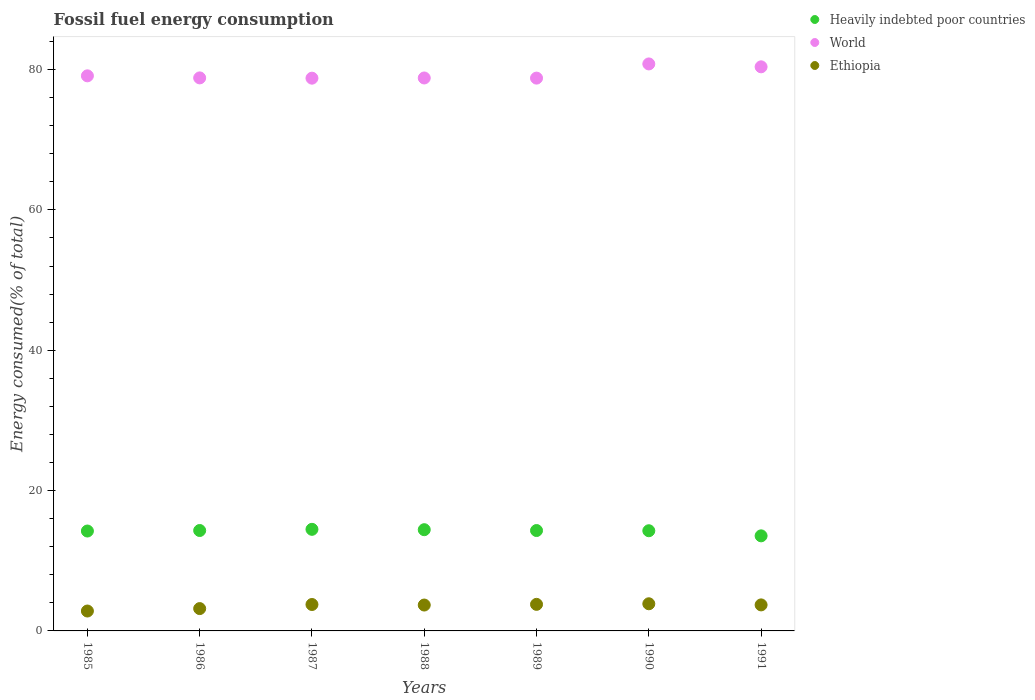How many different coloured dotlines are there?
Make the answer very short. 3. Is the number of dotlines equal to the number of legend labels?
Your answer should be very brief. Yes. What is the percentage of energy consumed in Ethiopia in 1985?
Make the answer very short. 2.84. Across all years, what is the maximum percentage of energy consumed in Heavily indebted poor countries?
Make the answer very short. 14.48. Across all years, what is the minimum percentage of energy consumed in World?
Your answer should be very brief. 78.77. In which year was the percentage of energy consumed in Ethiopia maximum?
Your response must be concise. 1990. What is the total percentage of energy consumed in Ethiopia in the graph?
Offer a very short reply. 24.83. What is the difference between the percentage of energy consumed in Ethiopia in 1987 and that in 1990?
Keep it short and to the point. -0.1. What is the difference between the percentage of energy consumed in World in 1989 and the percentage of energy consumed in Heavily indebted poor countries in 1986?
Provide a short and direct response. 64.47. What is the average percentage of energy consumed in Heavily indebted poor countries per year?
Your answer should be compact. 14.23. In the year 1988, what is the difference between the percentage of energy consumed in Ethiopia and percentage of energy consumed in World?
Provide a short and direct response. -75.11. What is the ratio of the percentage of energy consumed in World in 1985 to that in 1988?
Provide a short and direct response. 1. Is the difference between the percentage of energy consumed in Ethiopia in 1987 and 1990 greater than the difference between the percentage of energy consumed in World in 1987 and 1990?
Your answer should be compact. Yes. What is the difference between the highest and the second highest percentage of energy consumed in World?
Provide a short and direct response. 0.41. What is the difference between the highest and the lowest percentage of energy consumed in Heavily indebted poor countries?
Provide a succinct answer. 0.93. Is it the case that in every year, the sum of the percentage of energy consumed in World and percentage of energy consumed in Ethiopia  is greater than the percentage of energy consumed in Heavily indebted poor countries?
Offer a very short reply. Yes. Is the percentage of energy consumed in Ethiopia strictly greater than the percentage of energy consumed in Heavily indebted poor countries over the years?
Provide a succinct answer. No. Is the percentage of energy consumed in World strictly less than the percentage of energy consumed in Ethiopia over the years?
Your answer should be very brief. No. How many years are there in the graph?
Keep it short and to the point. 7. What is the difference between two consecutive major ticks on the Y-axis?
Offer a terse response. 20. Are the values on the major ticks of Y-axis written in scientific E-notation?
Your answer should be compact. No. Does the graph contain any zero values?
Give a very brief answer. No. What is the title of the graph?
Make the answer very short. Fossil fuel energy consumption. What is the label or title of the Y-axis?
Your answer should be very brief. Energy consumed(% of total). What is the Energy consumed(% of total) in Heavily indebted poor countries in 1985?
Your response must be concise. 14.24. What is the Energy consumed(% of total) in World in 1985?
Offer a terse response. 79.1. What is the Energy consumed(% of total) of Ethiopia in 1985?
Ensure brevity in your answer.  2.84. What is the Energy consumed(% of total) of Heavily indebted poor countries in 1986?
Offer a very short reply. 14.31. What is the Energy consumed(% of total) in World in 1986?
Ensure brevity in your answer.  78.81. What is the Energy consumed(% of total) in Ethiopia in 1986?
Make the answer very short. 3.18. What is the Energy consumed(% of total) in Heavily indebted poor countries in 1987?
Ensure brevity in your answer.  14.48. What is the Energy consumed(% of total) of World in 1987?
Your answer should be very brief. 78.77. What is the Energy consumed(% of total) of Ethiopia in 1987?
Offer a terse response. 3.76. What is the Energy consumed(% of total) in Heavily indebted poor countries in 1988?
Offer a very short reply. 14.43. What is the Energy consumed(% of total) in World in 1988?
Provide a short and direct response. 78.8. What is the Energy consumed(% of total) in Ethiopia in 1988?
Provide a succinct answer. 3.69. What is the Energy consumed(% of total) of Heavily indebted poor countries in 1989?
Keep it short and to the point. 14.31. What is the Energy consumed(% of total) of World in 1989?
Give a very brief answer. 78.78. What is the Energy consumed(% of total) in Ethiopia in 1989?
Your answer should be compact. 3.79. What is the Energy consumed(% of total) in Heavily indebted poor countries in 1990?
Keep it short and to the point. 14.28. What is the Energy consumed(% of total) of World in 1990?
Your response must be concise. 80.8. What is the Energy consumed(% of total) of Ethiopia in 1990?
Offer a terse response. 3.87. What is the Energy consumed(% of total) of Heavily indebted poor countries in 1991?
Make the answer very short. 13.55. What is the Energy consumed(% of total) of World in 1991?
Make the answer very short. 80.39. What is the Energy consumed(% of total) in Ethiopia in 1991?
Your answer should be compact. 3.71. Across all years, what is the maximum Energy consumed(% of total) in Heavily indebted poor countries?
Your answer should be very brief. 14.48. Across all years, what is the maximum Energy consumed(% of total) of World?
Offer a terse response. 80.8. Across all years, what is the maximum Energy consumed(% of total) of Ethiopia?
Give a very brief answer. 3.87. Across all years, what is the minimum Energy consumed(% of total) in Heavily indebted poor countries?
Offer a very short reply. 13.55. Across all years, what is the minimum Energy consumed(% of total) in World?
Your answer should be compact. 78.77. Across all years, what is the minimum Energy consumed(% of total) of Ethiopia?
Make the answer very short. 2.84. What is the total Energy consumed(% of total) in Heavily indebted poor countries in the graph?
Your response must be concise. 99.58. What is the total Energy consumed(% of total) of World in the graph?
Your answer should be compact. 555.46. What is the total Energy consumed(% of total) of Ethiopia in the graph?
Keep it short and to the point. 24.83. What is the difference between the Energy consumed(% of total) of Heavily indebted poor countries in 1985 and that in 1986?
Offer a terse response. -0.07. What is the difference between the Energy consumed(% of total) of World in 1985 and that in 1986?
Ensure brevity in your answer.  0.29. What is the difference between the Energy consumed(% of total) of Ethiopia in 1985 and that in 1986?
Your answer should be compact. -0.35. What is the difference between the Energy consumed(% of total) of Heavily indebted poor countries in 1985 and that in 1987?
Offer a terse response. -0.24. What is the difference between the Energy consumed(% of total) of World in 1985 and that in 1987?
Provide a short and direct response. 0.33. What is the difference between the Energy consumed(% of total) of Ethiopia in 1985 and that in 1987?
Provide a succinct answer. -0.93. What is the difference between the Energy consumed(% of total) of Heavily indebted poor countries in 1985 and that in 1988?
Your answer should be compact. -0.19. What is the difference between the Energy consumed(% of total) of World in 1985 and that in 1988?
Ensure brevity in your answer.  0.3. What is the difference between the Energy consumed(% of total) of Ethiopia in 1985 and that in 1988?
Ensure brevity in your answer.  -0.85. What is the difference between the Energy consumed(% of total) in Heavily indebted poor countries in 1985 and that in 1989?
Provide a short and direct response. -0.07. What is the difference between the Energy consumed(% of total) of World in 1985 and that in 1989?
Ensure brevity in your answer.  0.32. What is the difference between the Energy consumed(% of total) of Ethiopia in 1985 and that in 1989?
Offer a terse response. -0.95. What is the difference between the Energy consumed(% of total) in Heavily indebted poor countries in 1985 and that in 1990?
Offer a terse response. -0.04. What is the difference between the Energy consumed(% of total) of World in 1985 and that in 1990?
Your answer should be very brief. -1.7. What is the difference between the Energy consumed(% of total) in Ethiopia in 1985 and that in 1990?
Give a very brief answer. -1.03. What is the difference between the Energy consumed(% of total) of Heavily indebted poor countries in 1985 and that in 1991?
Provide a succinct answer. 0.69. What is the difference between the Energy consumed(% of total) in World in 1985 and that in 1991?
Your answer should be compact. -1.28. What is the difference between the Energy consumed(% of total) in Ethiopia in 1985 and that in 1991?
Provide a short and direct response. -0.87. What is the difference between the Energy consumed(% of total) of Heavily indebted poor countries in 1986 and that in 1987?
Give a very brief answer. -0.17. What is the difference between the Energy consumed(% of total) of World in 1986 and that in 1987?
Your response must be concise. 0.04. What is the difference between the Energy consumed(% of total) in Ethiopia in 1986 and that in 1987?
Provide a short and direct response. -0.58. What is the difference between the Energy consumed(% of total) in Heavily indebted poor countries in 1986 and that in 1988?
Provide a short and direct response. -0.12. What is the difference between the Energy consumed(% of total) of World in 1986 and that in 1988?
Ensure brevity in your answer.  0.01. What is the difference between the Energy consumed(% of total) in Ethiopia in 1986 and that in 1988?
Your answer should be compact. -0.51. What is the difference between the Energy consumed(% of total) in Heavily indebted poor countries in 1986 and that in 1989?
Give a very brief answer. 0. What is the difference between the Energy consumed(% of total) of World in 1986 and that in 1989?
Provide a succinct answer. 0.03. What is the difference between the Energy consumed(% of total) in Ethiopia in 1986 and that in 1989?
Your answer should be compact. -0.6. What is the difference between the Energy consumed(% of total) of Heavily indebted poor countries in 1986 and that in 1990?
Provide a succinct answer. 0.03. What is the difference between the Energy consumed(% of total) of World in 1986 and that in 1990?
Your answer should be very brief. -1.99. What is the difference between the Energy consumed(% of total) in Ethiopia in 1986 and that in 1990?
Provide a short and direct response. -0.69. What is the difference between the Energy consumed(% of total) of Heavily indebted poor countries in 1986 and that in 1991?
Ensure brevity in your answer.  0.76. What is the difference between the Energy consumed(% of total) in World in 1986 and that in 1991?
Give a very brief answer. -1.58. What is the difference between the Energy consumed(% of total) of Ethiopia in 1986 and that in 1991?
Offer a terse response. -0.53. What is the difference between the Energy consumed(% of total) in Heavily indebted poor countries in 1987 and that in 1988?
Give a very brief answer. 0.05. What is the difference between the Energy consumed(% of total) in World in 1987 and that in 1988?
Your response must be concise. -0.03. What is the difference between the Energy consumed(% of total) of Ethiopia in 1987 and that in 1988?
Give a very brief answer. 0.08. What is the difference between the Energy consumed(% of total) in Heavily indebted poor countries in 1987 and that in 1989?
Give a very brief answer. 0.17. What is the difference between the Energy consumed(% of total) of World in 1987 and that in 1989?
Your response must be concise. -0.01. What is the difference between the Energy consumed(% of total) of Ethiopia in 1987 and that in 1989?
Offer a very short reply. -0.02. What is the difference between the Energy consumed(% of total) in Heavily indebted poor countries in 1987 and that in 1990?
Ensure brevity in your answer.  0.2. What is the difference between the Energy consumed(% of total) of World in 1987 and that in 1990?
Ensure brevity in your answer.  -2.03. What is the difference between the Energy consumed(% of total) in Ethiopia in 1987 and that in 1990?
Your answer should be very brief. -0.1. What is the difference between the Energy consumed(% of total) in Heavily indebted poor countries in 1987 and that in 1991?
Provide a succinct answer. 0.93. What is the difference between the Energy consumed(% of total) of World in 1987 and that in 1991?
Offer a terse response. -1.62. What is the difference between the Energy consumed(% of total) of Ethiopia in 1987 and that in 1991?
Your response must be concise. 0.06. What is the difference between the Energy consumed(% of total) of Heavily indebted poor countries in 1988 and that in 1989?
Offer a very short reply. 0.12. What is the difference between the Energy consumed(% of total) of World in 1988 and that in 1989?
Your answer should be very brief. 0.02. What is the difference between the Energy consumed(% of total) of Ethiopia in 1988 and that in 1989?
Your answer should be compact. -0.1. What is the difference between the Energy consumed(% of total) of Heavily indebted poor countries in 1988 and that in 1990?
Offer a terse response. 0.15. What is the difference between the Energy consumed(% of total) of World in 1988 and that in 1990?
Offer a terse response. -2. What is the difference between the Energy consumed(% of total) of Ethiopia in 1988 and that in 1990?
Provide a succinct answer. -0.18. What is the difference between the Energy consumed(% of total) in Heavily indebted poor countries in 1988 and that in 1991?
Your answer should be compact. 0.88. What is the difference between the Energy consumed(% of total) of World in 1988 and that in 1991?
Offer a very short reply. -1.59. What is the difference between the Energy consumed(% of total) in Ethiopia in 1988 and that in 1991?
Offer a terse response. -0.02. What is the difference between the Energy consumed(% of total) in Heavily indebted poor countries in 1989 and that in 1990?
Your answer should be very brief. 0.03. What is the difference between the Energy consumed(% of total) in World in 1989 and that in 1990?
Keep it short and to the point. -2.02. What is the difference between the Energy consumed(% of total) in Ethiopia in 1989 and that in 1990?
Make the answer very short. -0.08. What is the difference between the Energy consumed(% of total) in Heavily indebted poor countries in 1989 and that in 1991?
Provide a short and direct response. 0.76. What is the difference between the Energy consumed(% of total) of World in 1989 and that in 1991?
Provide a short and direct response. -1.61. What is the difference between the Energy consumed(% of total) in Ethiopia in 1989 and that in 1991?
Offer a terse response. 0.08. What is the difference between the Energy consumed(% of total) of Heavily indebted poor countries in 1990 and that in 1991?
Your answer should be compact. 0.73. What is the difference between the Energy consumed(% of total) of World in 1990 and that in 1991?
Provide a succinct answer. 0.41. What is the difference between the Energy consumed(% of total) in Ethiopia in 1990 and that in 1991?
Provide a short and direct response. 0.16. What is the difference between the Energy consumed(% of total) in Heavily indebted poor countries in 1985 and the Energy consumed(% of total) in World in 1986?
Offer a terse response. -64.58. What is the difference between the Energy consumed(% of total) in Heavily indebted poor countries in 1985 and the Energy consumed(% of total) in Ethiopia in 1986?
Provide a short and direct response. 11.05. What is the difference between the Energy consumed(% of total) in World in 1985 and the Energy consumed(% of total) in Ethiopia in 1986?
Give a very brief answer. 75.92. What is the difference between the Energy consumed(% of total) in Heavily indebted poor countries in 1985 and the Energy consumed(% of total) in World in 1987?
Offer a very short reply. -64.54. What is the difference between the Energy consumed(% of total) of Heavily indebted poor countries in 1985 and the Energy consumed(% of total) of Ethiopia in 1987?
Provide a short and direct response. 10.47. What is the difference between the Energy consumed(% of total) of World in 1985 and the Energy consumed(% of total) of Ethiopia in 1987?
Provide a succinct answer. 75.34. What is the difference between the Energy consumed(% of total) in Heavily indebted poor countries in 1985 and the Energy consumed(% of total) in World in 1988?
Keep it short and to the point. -64.56. What is the difference between the Energy consumed(% of total) of Heavily indebted poor countries in 1985 and the Energy consumed(% of total) of Ethiopia in 1988?
Make the answer very short. 10.55. What is the difference between the Energy consumed(% of total) in World in 1985 and the Energy consumed(% of total) in Ethiopia in 1988?
Make the answer very short. 75.42. What is the difference between the Energy consumed(% of total) of Heavily indebted poor countries in 1985 and the Energy consumed(% of total) of World in 1989?
Ensure brevity in your answer.  -64.54. What is the difference between the Energy consumed(% of total) of Heavily indebted poor countries in 1985 and the Energy consumed(% of total) of Ethiopia in 1989?
Make the answer very short. 10.45. What is the difference between the Energy consumed(% of total) in World in 1985 and the Energy consumed(% of total) in Ethiopia in 1989?
Give a very brief answer. 75.32. What is the difference between the Energy consumed(% of total) of Heavily indebted poor countries in 1985 and the Energy consumed(% of total) of World in 1990?
Your answer should be compact. -66.57. What is the difference between the Energy consumed(% of total) of Heavily indebted poor countries in 1985 and the Energy consumed(% of total) of Ethiopia in 1990?
Provide a short and direct response. 10.37. What is the difference between the Energy consumed(% of total) in World in 1985 and the Energy consumed(% of total) in Ethiopia in 1990?
Provide a short and direct response. 75.24. What is the difference between the Energy consumed(% of total) in Heavily indebted poor countries in 1985 and the Energy consumed(% of total) in World in 1991?
Provide a short and direct response. -66.15. What is the difference between the Energy consumed(% of total) of Heavily indebted poor countries in 1985 and the Energy consumed(% of total) of Ethiopia in 1991?
Provide a succinct answer. 10.53. What is the difference between the Energy consumed(% of total) in World in 1985 and the Energy consumed(% of total) in Ethiopia in 1991?
Offer a very short reply. 75.4. What is the difference between the Energy consumed(% of total) in Heavily indebted poor countries in 1986 and the Energy consumed(% of total) in World in 1987?
Offer a terse response. -64.46. What is the difference between the Energy consumed(% of total) in Heavily indebted poor countries in 1986 and the Energy consumed(% of total) in Ethiopia in 1987?
Provide a short and direct response. 10.55. What is the difference between the Energy consumed(% of total) in World in 1986 and the Energy consumed(% of total) in Ethiopia in 1987?
Ensure brevity in your answer.  75.05. What is the difference between the Energy consumed(% of total) in Heavily indebted poor countries in 1986 and the Energy consumed(% of total) in World in 1988?
Offer a very short reply. -64.49. What is the difference between the Energy consumed(% of total) of Heavily indebted poor countries in 1986 and the Energy consumed(% of total) of Ethiopia in 1988?
Offer a very short reply. 10.62. What is the difference between the Energy consumed(% of total) of World in 1986 and the Energy consumed(% of total) of Ethiopia in 1988?
Give a very brief answer. 75.12. What is the difference between the Energy consumed(% of total) in Heavily indebted poor countries in 1986 and the Energy consumed(% of total) in World in 1989?
Give a very brief answer. -64.47. What is the difference between the Energy consumed(% of total) in Heavily indebted poor countries in 1986 and the Energy consumed(% of total) in Ethiopia in 1989?
Offer a very short reply. 10.52. What is the difference between the Energy consumed(% of total) in World in 1986 and the Energy consumed(% of total) in Ethiopia in 1989?
Keep it short and to the point. 75.03. What is the difference between the Energy consumed(% of total) in Heavily indebted poor countries in 1986 and the Energy consumed(% of total) in World in 1990?
Keep it short and to the point. -66.49. What is the difference between the Energy consumed(% of total) in Heavily indebted poor countries in 1986 and the Energy consumed(% of total) in Ethiopia in 1990?
Provide a succinct answer. 10.44. What is the difference between the Energy consumed(% of total) in World in 1986 and the Energy consumed(% of total) in Ethiopia in 1990?
Make the answer very short. 74.94. What is the difference between the Energy consumed(% of total) in Heavily indebted poor countries in 1986 and the Energy consumed(% of total) in World in 1991?
Give a very brief answer. -66.08. What is the difference between the Energy consumed(% of total) in Heavily indebted poor countries in 1986 and the Energy consumed(% of total) in Ethiopia in 1991?
Ensure brevity in your answer.  10.6. What is the difference between the Energy consumed(% of total) in World in 1986 and the Energy consumed(% of total) in Ethiopia in 1991?
Provide a succinct answer. 75.1. What is the difference between the Energy consumed(% of total) in Heavily indebted poor countries in 1987 and the Energy consumed(% of total) in World in 1988?
Your response must be concise. -64.32. What is the difference between the Energy consumed(% of total) in Heavily indebted poor countries in 1987 and the Energy consumed(% of total) in Ethiopia in 1988?
Keep it short and to the point. 10.79. What is the difference between the Energy consumed(% of total) in World in 1987 and the Energy consumed(% of total) in Ethiopia in 1988?
Offer a very short reply. 75.08. What is the difference between the Energy consumed(% of total) in Heavily indebted poor countries in 1987 and the Energy consumed(% of total) in World in 1989?
Your answer should be very brief. -64.3. What is the difference between the Energy consumed(% of total) of Heavily indebted poor countries in 1987 and the Energy consumed(% of total) of Ethiopia in 1989?
Your answer should be very brief. 10.69. What is the difference between the Energy consumed(% of total) of World in 1987 and the Energy consumed(% of total) of Ethiopia in 1989?
Provide a short and direct response. 74.99. What is the difference between the Energy consumed(% of total) of Heavily indebted poor countries in 1987 and the Energy consumed(% of total) of World in 1990?
Offer a very short reply. -66.32. What is the difference between the Energy consumed(% of total) in Heavily indebted poor countries in 1987 and the Energy consumed(% of total) in Ethiopia in 1990?
Keep it short and to the point. 10.61. What is the difference between the Energy consumed(% of total) in World in 1987 and the Energy consumed(% of total) in Ethiopia in 1990?
Keep it short and to the point. 74.9. What is the difference between the Energy consumed(% of total) of Heavily indebted poor countries in 1987 and the Energy consumed(% of total) of World in 1991?
Give a very brief answer. -65.91. What is the difference between the Energy consumed(% of total) of Heavily indebted poor countries in 1987 and the Energy consumed(% of total) of Ethiopia in 1991?
Ensure brevity in your answer.  10.77. What is the difference between the Energy consumed(% of total) in World in 1987 and the Energy consumed(% of total) in Ethiopia in 1991?
Your answer should be very brief. 75.06. What is the difference between the Energy consumed(% of total) of Heavily indebted poor countries in 1988 and the Energy consumed(% of total) of World in 1989?
Your answer should be very brief. -64.35. What is the difference between the Energy consumed(% of total) in Heavily indebted poor countries in 1988 and the Energy consumed(% of total) in Ethiopia in 1989?
Provide a succinct answer. 10.64. What is the difference between the Energy consumed(% of total) in World in 1988 and the Energy consumed(% of total) in Ethiopia in 1989?
Ensure brevity in your answer.  75.01. What is the difference between the Energy consumed(% of total) in Heavily indebted poor countries in 1988 and the Energy consumed(% of total) in World in 1990?
Your answer should be very brief. -66.38. What is the difference between the Energy consumed(% of total) in Heavily indebted poor countries in 1988 and the Energy consumed(% of total) in Ethiopia in 1990?
Your answer should be compact. 10.56. What is the difference between the Energy consumed(% of total) of World in 1988 and the Energy consumed(% of total) of Ethiopia in 1990?
Your response must be concise. 74.93. What is the difference between the Energy consumed(% of total) of Heavily indebted poor countries in 1988 and the Energy consumed(% of total) of World in 1991?
Provide a short and direct response. -65.96. What is the difference between the Energy consumed(% of total) in Heavily indebted poor countries in 1988 and the Energy consumed(% of total) in Ethiopia in 1991?
Make the answer very short. 10.72. What is the difference between the Energy consumed(% of total) of World in 1988 and the Energy consumed(% of total) of Ethiopia in 1991?
Your answer should be compact. 75.09. What is the difference between the Energy consumed(% of total) in Heavily indebted poor countries in 1989 and the Energy consumed(% of total) in World in 1990?
Your answer should be very brief. -66.5. What is the difference between the Energy consumed(% of total) in Heavily indebted poor countries in 1989 and the Energy consumed(% of total) in Ethiopia in 1990?
Your response must be concise. 10.44. What is the difference between the Energy consumed(% of total) in World in 1989 and the Energy consumed(% of total) in Ethiopia in 1990?
Your answer should be compact. 74.91. What is the difference between the Energy consumed(% of total) in Heavily indebted poor countries in 1989 and the Energy consumed(% of total) in World in 1991?
Give a very brief answer. -66.08. What is the difference between the Energy consumed(% of total) of Heavily indebted poor countries in 1989 and the Energy consumed(% of total) of Ethiopia in 1991?
Provide a short and direct response. 10.6. What is the difference between the Energy consumed(% of total) in World in 1989 and the Energy consumed(% of total) in Ethiopia in 1991?
Your response must be concise. 75.07. What is the difference between the Energy consumed(% of total) of Heavily indebted poor countries in 1990 and the Energy consumed(% of total) of World in 1991?
Offer a terse response. -66.11. What is the difference between the Energy consumed(% of total) of Heavily indebted poor countries in 1990 and the Energy consumed(% of total) of Ethiopia in 1991?
Give a very brief answer. 10.57. What is the difference between the Energy consumed(% of total) in World in 1990 and the Energy consumed(% of total) in Ethiopia in 1991?
Offer a very short reply. 77.09. What is the average Energy consumed(% of total) of Heavily indebted poor countries per year?
Make the answer very short. 14.23. What is the average Energy consumed(% of total) of World per year?
Make the answer very short. 79.35. What is the average Energy consumed(% of total) in Ethiopia per year?
Make the answer very short. 3.55. In the year 1985, what is the difference between the Energy consumed(% of total) of Heavily indebted poor countries and Energy consumed(% of total) of World?
Provide a succinct answer. -64.87. In the year 1985, what is the difference between the Energy consumed(% of total) of Heavily indebted poor countries and Energy consumed(% of total) of Ethiopia?
Keep it short and to the point. 11.4. In the year 1985, what is the difference between the Energy consumed(% of total) of World and Energy consumed(% of total) of Ethiopia?
Your answer should be compact. 76.27. In the year 1986, what is the difference between the Energy consumed(% of total) of Heavily indebted poor countries and Energy consumed(% of total) of World?
Your response must be concise. -64.5. In the year 1986, what is the difference between the Energy consumed(% of total) of Heavily indebted poor countries and Energy consumed(% of total) of Ethiopia?
Your response must be concise. 11.13. In the year 1986, what is the difference between the Energy consumed(% of total) in World and Energy consumed(% of total) in Ethiopia?
Your answer should be compact. 75.63. In the year 1987, what is the difference between the Energy consumed(% of total) in Heavily indebted poor countries and Energy consumed(% of total) in World?
Your answer should be compact. -64.29. In the year 1987, what is the difference between the Energy consumed(% of total) of Heavily indebted poor countries and Energy consumed(% of total) of Ethiopia?
Ensure brevity in your answer.  10.71. In the year 1987, what is the difference between the Energy consumed(% of total) of World and Energy consumed(% of total) of Ethiopia?
Offer a terse response. 75.01. In the year 1988, what is the difference between the Energy consumed(% of total) in Heavily indebted poor countries and Energy consumed(% of total) in World?
Offer a terse response. -64.37. In the year 1988, what is the difference between the Energy consumed(% of total) in Heavily indebted poor countries and Energy consumed(% of total) in Ethiopia?
Your answer should be compact. 10.74. In the year 1988, what is the difference between the Energy consumed(% of total) of World and Energy consumed(% of total) of Ethiopia?
Keep it short and to the point. 75.11. In the year 1989, what is the difference between the Energy consumed(% of total) in Heavily indebted poor countries and Energy consumed(% of total) in World?
Your answer should be very brief. -64.47. In the year 1989, what is the difference between the Energy consumed(% of total) of Heavily indebted poor countries and Energy consumed(% of total) of Ethiopia?
Make the answer very short. 10.52. In the year 1989, what is the difference between the Energy consumed(% of total) in World and Energy consumed(% of total) in Ethiopia?
Make the answer very short. 75. In the year 1990, what is the difference between the Energy consumed(% of total) of Heavily indebted poor countries and Energy consumed(% of total) of World?
Offer a very short reply. -66.52. In the year 1990, what is the difference between the Energy consumed(% of total) in Heavily indebted poor countries and Energy consumed(% of total) in Ethiopia?
Give a very brief answer. 10.41. In the year 1990, what is the difference between the Energy consumed(% of total) in World and Energy consumed(% of total) in Ethiopia?
Keep it short and to the point. 76.93. In the year 1991, what is the difference between the Energy consumed(% of total) of Heavily indebted poor countries and Energy consumed(% of total) of World?
Make the answer very short. -66.84. In the year 1991, what is the difference between the Energy consumed(% of total) in Heavily indebted poor countries and Energy consumed(% of total) in Ethiopia?
Provide a short and direct response. 9.84. In the year 1991, what is the difference between the Energy consumed(% of total) of World and Energy consumed(% of total) of Ethiopia?
Offer a very short reply. 76.68. What is the ratio of the Energy consumed(% of total) of Heavily indebted poor countries in 1985 to that in 1986?
Your answer should be very brief. 0.99. What is the ratio of the Energy consumed(% of total) of World in 1985 to that in 1986?
Make the answer very short. 1. What is the ratio of the Energy consumed(% of total) of Ethiopia in 1985 to that in 1986?
Provide a short and direct response. 0.89. What is the ratio of the Energy consumed(% of total) in Heavily indebted poor countries in 1985 to that in 1987?
Offer a very short reply. 0.98. What is the ratio of the Energy consumed(% of total) of World in 1985 to that in 1987?
Offer a terse response. 1. What is the ratio of the Energy consumed(% of total) in Ethiopia in 1985 to that in 1987?
Ensure brevity in your answer.  0.75. What is the ratio of the Energy consumed(% of total) in Heavily indebted poor countries in 1985 to that in 1988?
Your answer should be compact. 0.99. What is the ratio of the Energy consumed(% of total) of Ethiopia in 1985 to that in 1988?
Give a very brief answer. 0.77. What is the ratio of the Energy consumed(% of total) of Heavily indebted poor countries in 1985 to that in 1989?
Keep it short and to the point. 1. What is the ratio of the Energy consumed(% of total) in Ethiopia in 1985 to that in 1989?
Make the answer very short. 0.75. What is the ratio of the Energy consumed(% of total) of Heavily indebted poor countries in 1985 to that in 1990?
Provide a short and direct response. 1. What is the ratio of the Energy consumed(% of total) in Ethiopia in 1985 to that in 1990?
Give a very brief answer. 0.73. What is the ratio of the Energy consumed(% of total) in Heavily indebted poor countries in 1985 to that in 1991?
Provide a short and direct response. 1.05. What is the ratio of the Energy consumed(% of total) in Ethiopia in 1985 to that in 1991?
Offer a terse response. 0.76. What is the ratio of the Energy consumed(% of total) of Heavily indebted poor countries in 1986 to that in 1987?
Keep it short and to the point. 0.99. What is the ratio of the Energy consumed(% of total) in World in 1986 to that in 1987?
Keep it short and to the point. 1. What is the ratio of the Energy consumed(% of total) in Ethiopia in 1986 to that in 1987?
Your answer should be very brief. 0.85. What is the ratio of the Energy consumed(% of total) in Ethiopia in 1986 to that in 1988?
Keep it short and to the point. 0.86. What is the ratio of the Energy consumed(% of total) of Ethiopia in 1986 to that in 1989?
Give a very brief answer. 0.84. What is the ratio of the Energy consumed(% of total) of World in 1986 to that in 1990?
Give a very brief answer. 0.98. What is the ratio of the Energy consumed(% of total) of Ethiopia in 1986 to that in 1990?
Give a very brief answer. 0.82. What is the ratio of the Energy consumed(% of total) of Heavily indebted poor countries in 1986 to that in 1991?
Give a very brief answer. 1.06. What is the ratio of the Energy consumed(% of total) in World in 1986 to that in 1991?
Provide a succinct answer. 0.98. What is the ratio of the Energy consumed(% of total) in Ethiopia in 1986 to that in 1991?
Offer a terse response. 0.86. What is the ratio of the Energy consumed(% of total) in Ethiopia in 1987 to that in 1988?
Offer a terse response. 1.02. What is the ratio of the Energy consumed(% of total) of Heavily indebted poor countries in 1987 to that in 1989?
Make the answer very short. 1.01. What is the ratio of the Energy consumed(% of total) in World in 1987 to that in 1989?
Make the answer very short. 1. What is the ratio of the Energy consumed(% of total) in Heavily indebted poor countries in 1987 to that in 1990?
Provide a short and direct response. 1.01. What is the ratio of the Energy consumed(% of total) of World in 1987 to that in 1990?
Ensure brevity in your answer.  0.97. What is the ratio of the Energy consumed(% of total) in Ethiopia in 1987 to that in 1990?
Give a very brief answer. 0.97. What is the ratio of the Energy consumed(% of total) of Heavily indebted poor countries in 1987 to that in 1991?
Provide a short and direct response. 1.07. What is the ratio of the Energy consumed(% of total) in World in 1987 to that in 1991?
Offer a terse response. 0.98. What is the ratio of the Energy consumed(% of total) in Ethiopia in 1987 to that in 1991?
Make the answer very short. 1.02. What is the ratio of the Energy consumed(% of total) of Heavily indebted poor countries in 1988 to that in 1989?
Provide a succinct answer. 1.01. What is the ratio of the Energy consumed(% of total) in Ethiopia in 1988 to that in 1989?
Your response must be concise. 0.97. What is the ratio of the Energy consumed(% of total) in Heavily indebted poor countries in 1988 to that in 1990?
Ensure brevity in your answer.  1.01. What is the ratio of the Energy consumed(% of total) of World in 1988 to that in 1990?
Your answer should be very brief. 0.98. What is the ratio of the Energy consumed(% of total) in Ethiopia in 1988 to that in 1990?
Offer a terse response. 0.95. What is the ratio of the Energy consumed(% of total) of Heavily indebted poor countries in 1988 to that in 1991?
Offer a terse response. 1.06. What is the ratio of the Energy consumed(% of total) of World in 1988 to that in 1991?
Offer a very short reply. 0.98. What is the ratio of the Energy consumed(% of total) in World in 1989 to that in 1990?
Offer a very short reply. 0.97. What is the ratio of the Energy consumed(% of total) of Ethiopia in 1989 to that in 1990?
Your answer should be compact. 0.98. What is the ratio of the Energy consumed(% of total) of Heavily indebted poor countries in 1989 to that in 1991?
Provide a succinct answer. 1.06. What is the ratio of the Energy consumed(% of total) of World in 1989 to that in 1991?
Keep it short and to the point. 0.98. What is the ratio of the Energy consumed(% of total) of Ethiopia in 1989 to that in 1991?
Provide a short and direct response. 1.02. What is the ratio of the Energy consumed(% of total) in Heavily indebted poor countries in 1990 to that in 1991?
Provide a succinct answer. 1.05. What is the ratio of the Energy consumed(% of total) of World in 1990 to that in 1991?
Your answer should be compact. 1.01. What is the ratio of the Energy consumed(% of total) in Ethiopia in 1990 to that in 1991?
Offer a terse response. 1.04. What is the difference between the highest and the second highest Energy consumed(% of total) in Heavily indebted poor countries?
Your answer should be compact. 0.05. What is the difference between the highest and the second highest Energy consumed(% of total) in World?
Your response must be concise. 0.41. What is the difference between the highest and the second highest Energy consumed(% of total) of Ethiopia?
Your answer should be compact. 0.08. What is the difference between the highest and the lowest Energy consumed(% of total) of Heavily indebted poor countries?
Your answer should be very brief. 0.93. What is the difference between the highest and the lowest Energy consumed(% of total) in World?
Keep it short and to the point. 2.03. What is the difference between the highest and the lowest Energy consumed(% of total) in Ethiopia?
Give a very brief answer. 1.03. 